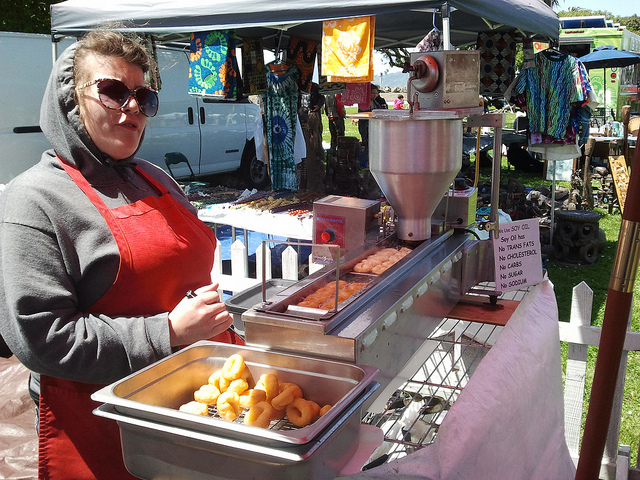<image>What is the man with the orange pants eating? It is not known what the man with the orange pants is eating. However, there is no man with orange pants in the image. What is the man with the orange pants eating? I am not sure what the man with the orange pants is eating. It can be seen as onion rings, peaches, or donuts. 